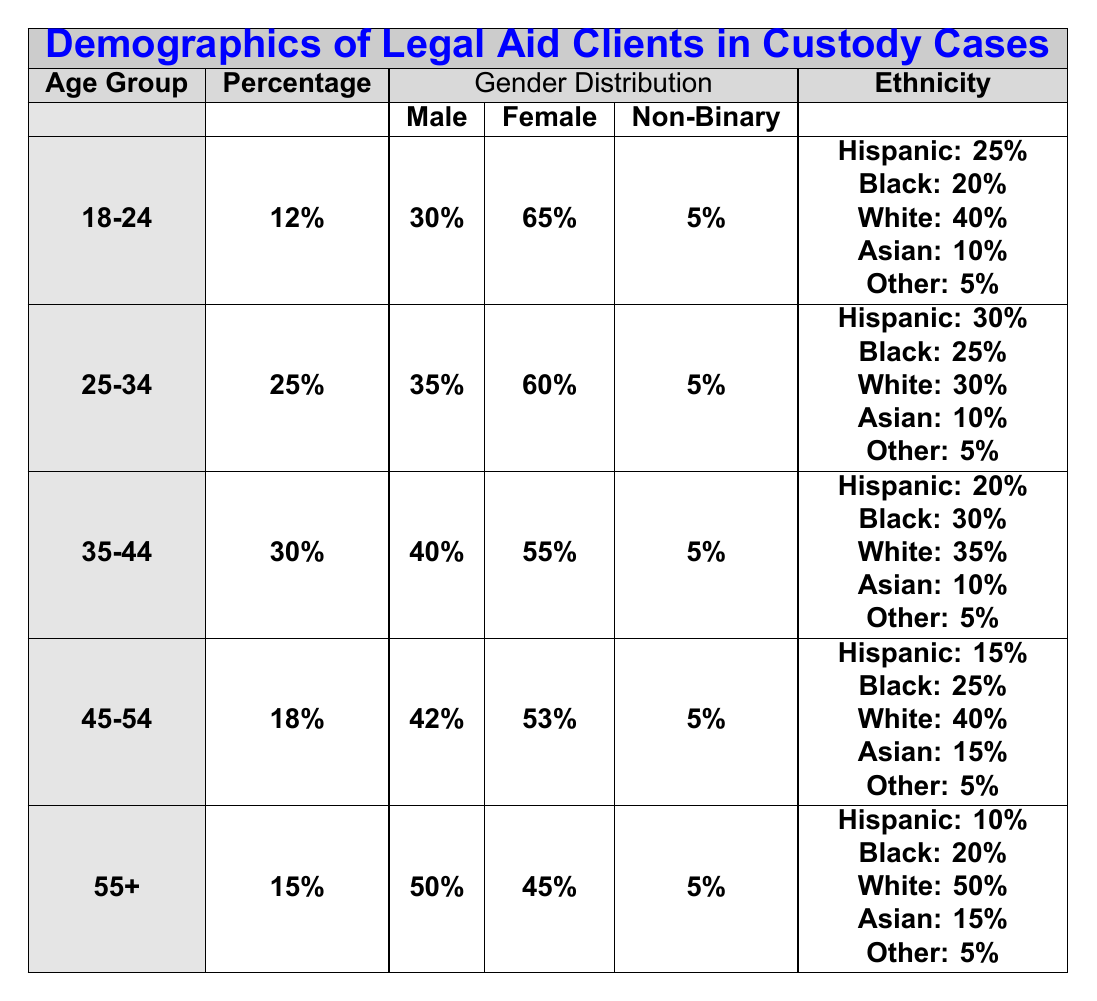What percentage of legal aid clients in custody cases are aged 25-34? The table indicates that 25% of legal aid clients fall within the age group of 25-34.
Answer: 25% Which gender has the highest representation among clients aged 35-44? The gender distribution for the age group 35-44 shows that female clients represent 55%, which is higher than the 40% of male clients.
Answer: Female What is the combined percentage of Hispanic clients across all age groups? Adding up the percentage of Hispanic clients from all age groups: 25% (18-24) + 30% (25-34) + 20% (35-44) + 15% (45-54) + 10% (55+) = 100%.
Answer: 100% Is the percentage of male clients higher in the age group 45-54 compared to the age group 18-24? The male percentage in the 45-54 age group is 42%, while in the 18-24 age group it is 30%. Since 42% is greater than 30%, the statement is true.
Answer: Yes What percentage of clients aged 55 and older identify as non-binary? The table shows that in the age group of 55+, the non-binary clients make up 5%.
Answer: 5% What is the gender distribution for clients aged 25-34? The gender distribution for clients aged 25-34 is 35% male, 60% female, and 5% non-binary.
Answer: 35% male, 60% female, 5% non-binary Which age group has the highest percentage of legal aid clients? The age group 35-44 has the highest percentage at 30% compared to other age groups.
Answer: 35-44 How many clients in the 45-54 age group identify as Hispanic and what percentage is this of the total clients in that age group? There are 15% Hispanic clients in the 45-54 age group out of a total of 18% clients in that age group, calculated as (15/18)*100 = 83.33%.
Answer: 15% Hispanic (83.33% of total in that age group) What are the ethnicities of clients aged 18-24? For the age group 18-24, the ethnicities listed are 25% Hispanic, 20% Black, 40% White, 10% Asian, and 5% Other.
Answer: 25% Hispanic, 20% Black, 40% White, 10% Asian, 5% Other Which age group has the lowest percentage of legal aid clients and what is that percentage? The age group 18-24 has the lowest percentage of legal aid clients at 12%.
Answer: 12% 